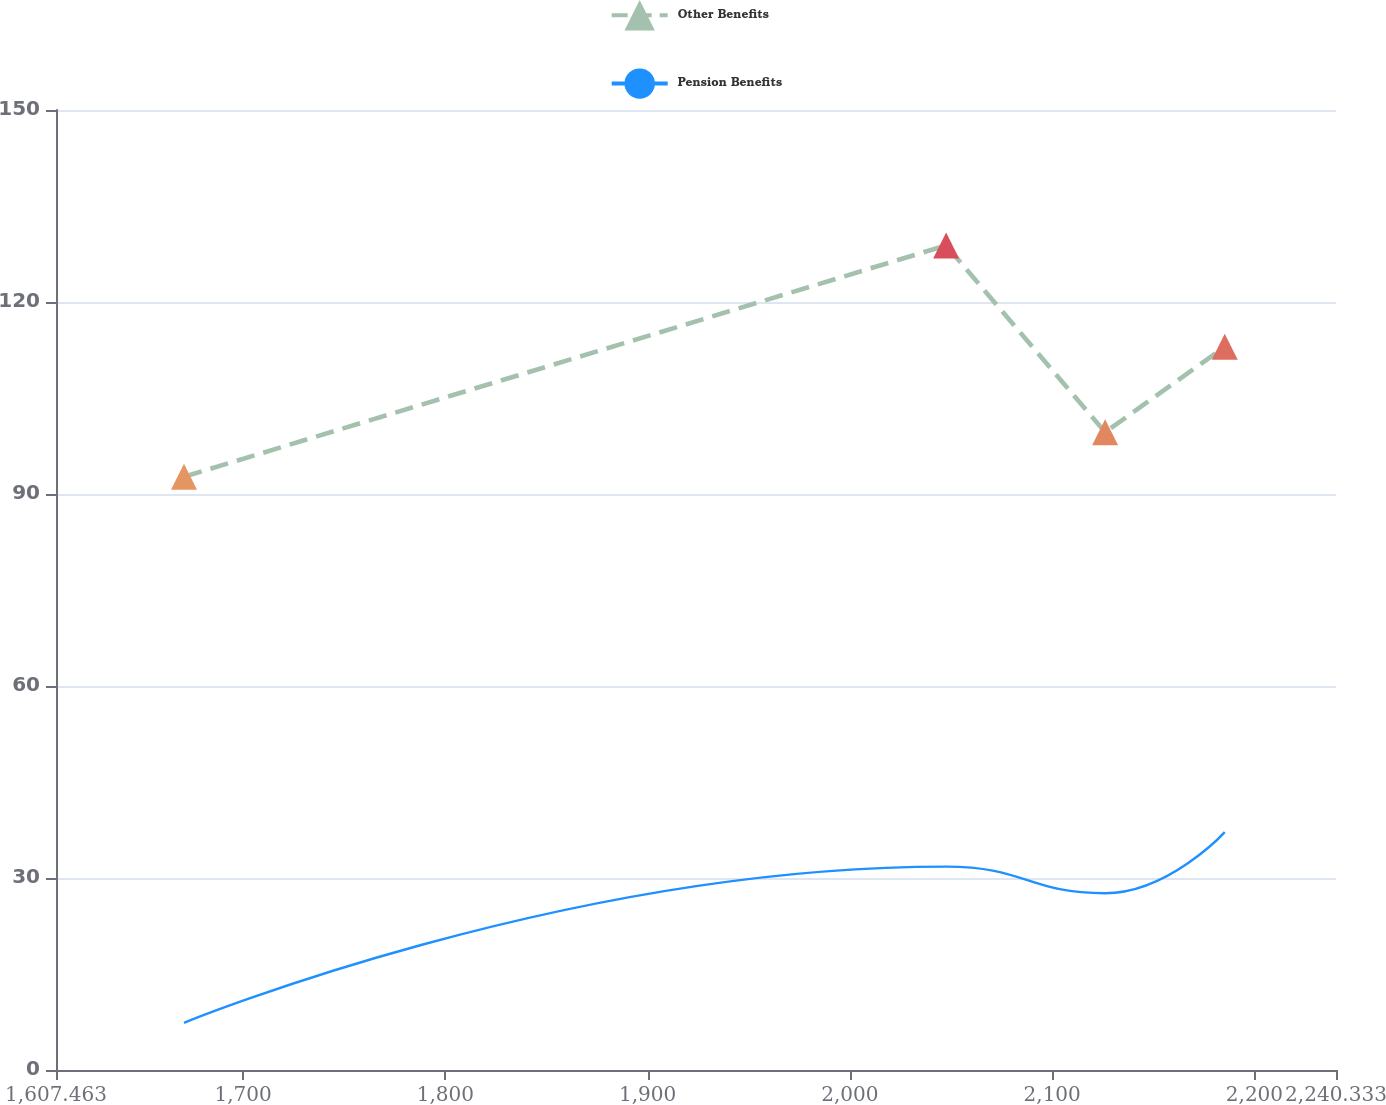Convert chart to OTSL. <chart><loc_0><loc_0><loc_500><loc_500><line_chart><ecel><fcel>Other Benefits<fcel>Pension Benefits<nl><fcel>1670.75<fcel>92.7<fcel>7.37<nl><fcel>2047.57<fcel>128.84<fcel>31.78<nl><fcel>2126.17<fcel>99.64<fcel>27.62<nl><fcel>2185.32<fcel>113.01<fcel>37.16<nl><fcel>2244.47<fcel>109.4<fcel>44<nl><fcel>2303.62<fcel>105.79<fcel>48.04<nl></chart> 